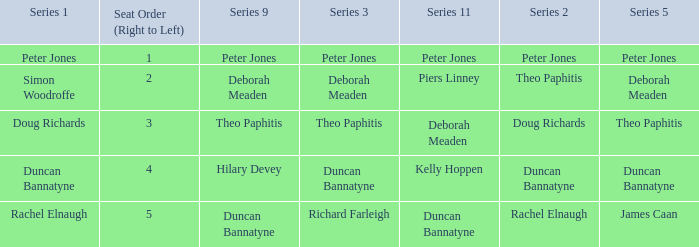Which Series 2 has a Series 3 of deborah meaden? Theo Paphitis. 